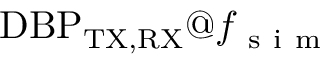Convert formula to latex. <formula><loc_0><loc_0><loc_500><loc_500>D B P _ { T X , R X } f _ { s i m }</formula> 